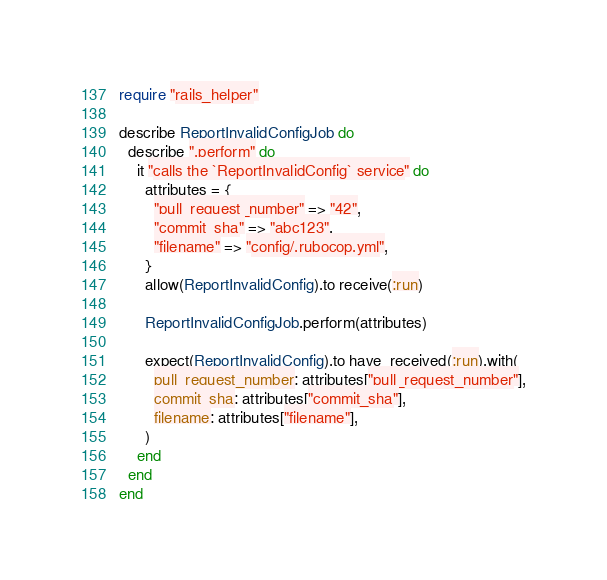Convert code to text. <code><loc_0><loc_0><loc_500><loc_500><_Ruby_>require "rails_helper"

describe ReportInvalidConfigJob do
  describe ".perform" do
    it "calls the `ReportInvalidConfig` service" do
      attributes = {
        "pull_request_number" => "42",
        "commit_sha" => "abc123",
        "filename" => "config/.rubocop.yml",
      }
      allow(ReportInvalidConfig).to receive(:run)

      ReportInvalidConfigJob.perform(attributes)

      expect(ReportInvalidConfig).to have_received(:run).with(
        pull_request_number: attributes["pull_request_number"],
        commit_sha: attributes["commit_sha"],
        filename: attributes["filename"],
      )
    end
  end
end
</code> 